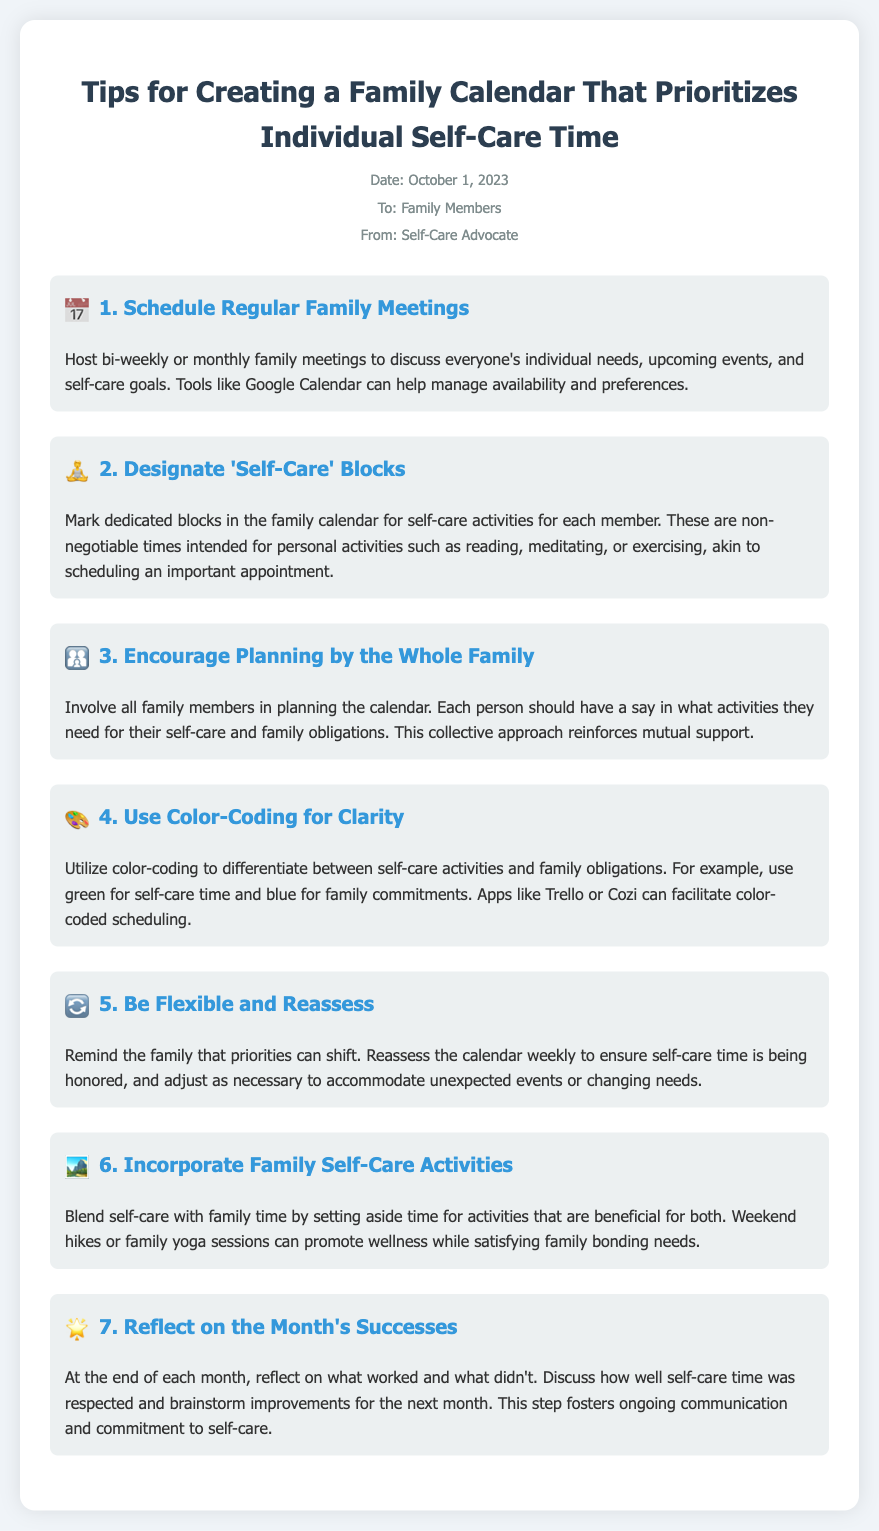What is the date of the memo? The date of the memo is mentioned at the top under the meta information.
Answer: October 1, 2023 Who is the memo addressed to? The memo includes information on the recipient in the meta section.
Answer: Family Members What is the main purpose of the family meetings? The document states that family meetings are for discussing individual needs and upcoming events.
Answer: Discuss everyone's individual needs How often should family meetings be held? The memo suggests a frequency for hosting family meetings.
Answer: Bi-weekly or monthly What color is suggested for self-care time in the calendar? The memo specifies a color to differentiate self-care activities from family obligations.
Answer: Green What should families do at the end of each month? The document describes an activity for reflection at the end of the month.
Answer: Reflect on the month's successes How can self-care be incorporated with family time? The memo provides examples of activities that promote wellness and bonding.
Answer: Weekend hikes or family yoga sessions What tool can help manage everyone's availability for family meetings? The document mentions a tool that can assist in managing schedules and preferences.
Answer: Google Calendar 